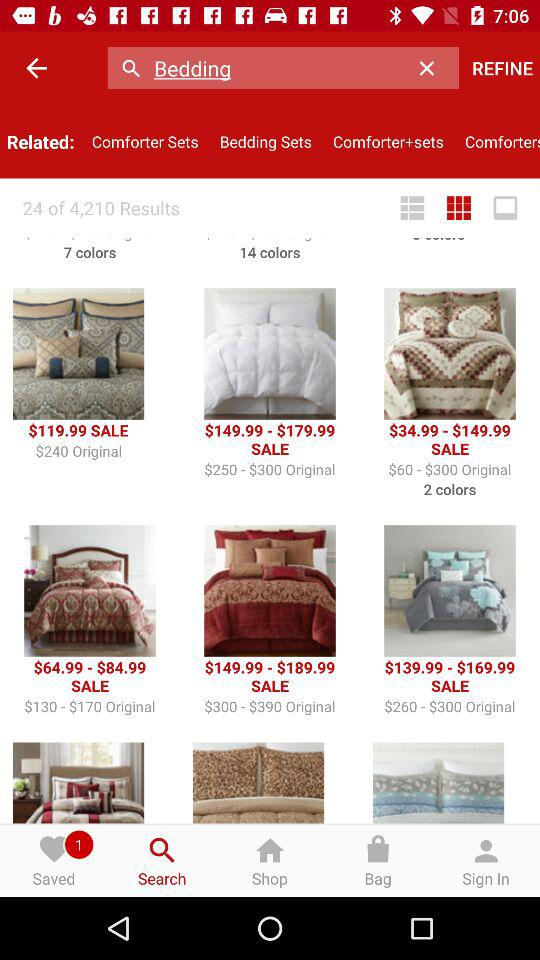What is the total number of results given in the list? The total number of results given in the list is 4,210. 